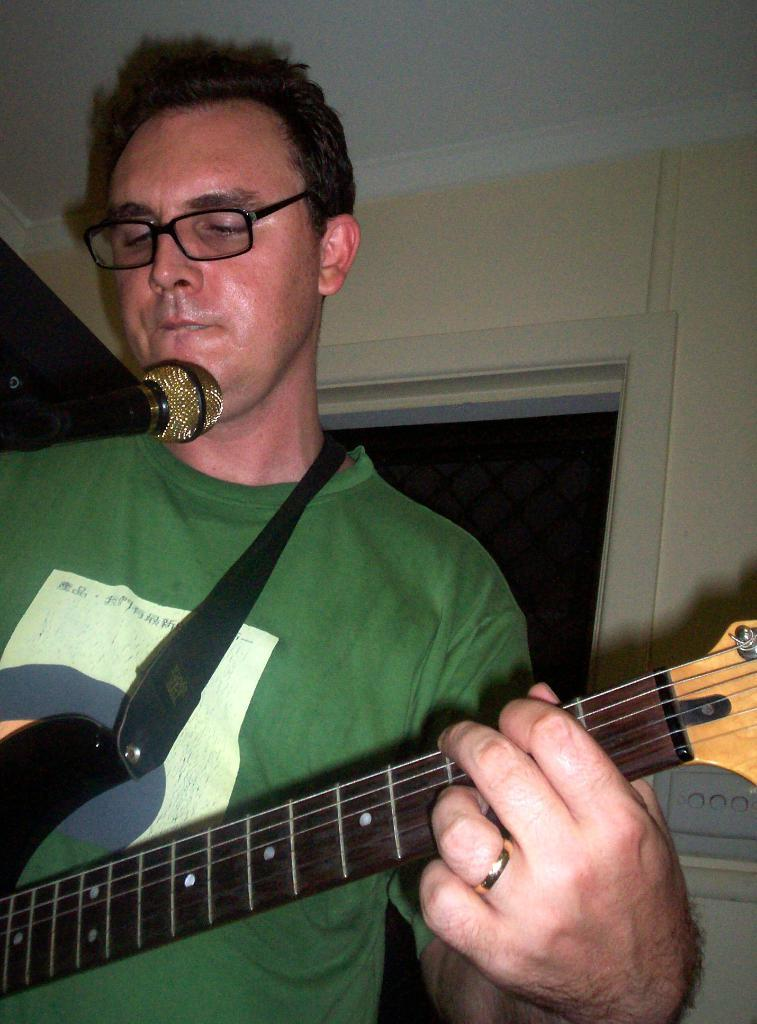What is the man in the image doing? The man is playing the guitar. What object is the man holding while playing the guitar? The man is holding a guitar. Where is the man positioned in relation to the microphone? The man is in front of a microphone. What can be seen in the background of the image? There is a wall and a ceiling in the background of the image. What color is the T-shirt the man is wearing? The man is wearing a green T-shirt. What type of territory is the man trying to claim in the image? There is no indication of territory or claiming in the image; the man is playing the guitar and standing in front of a microphone. 